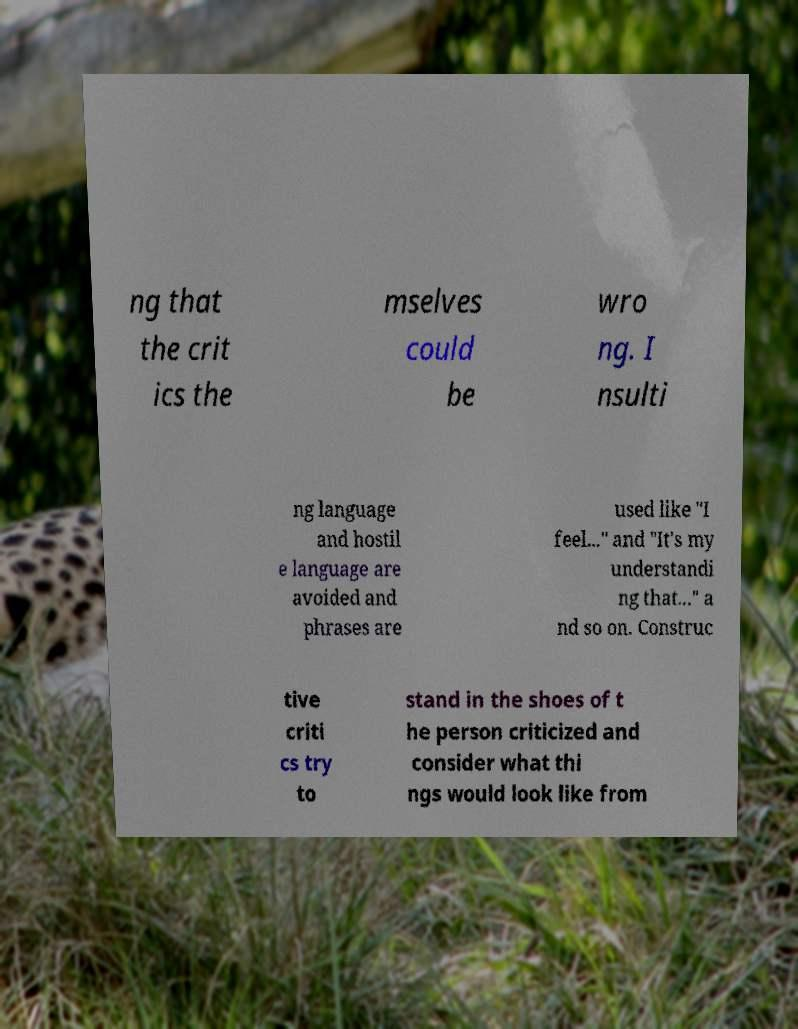There's text embedded in this image that I need extracted. Can you transcribe it verbatim? ng that the crit ics the mselves could be wro ng. I nsulti ng language and hostil e language are avoided and phrases are used like "I feel..." and "It's my understandi ng that..." a nd so on. Construc tive criti cs try to stand in the shoes of t he person criticized and consider what thi ngs would look like from 